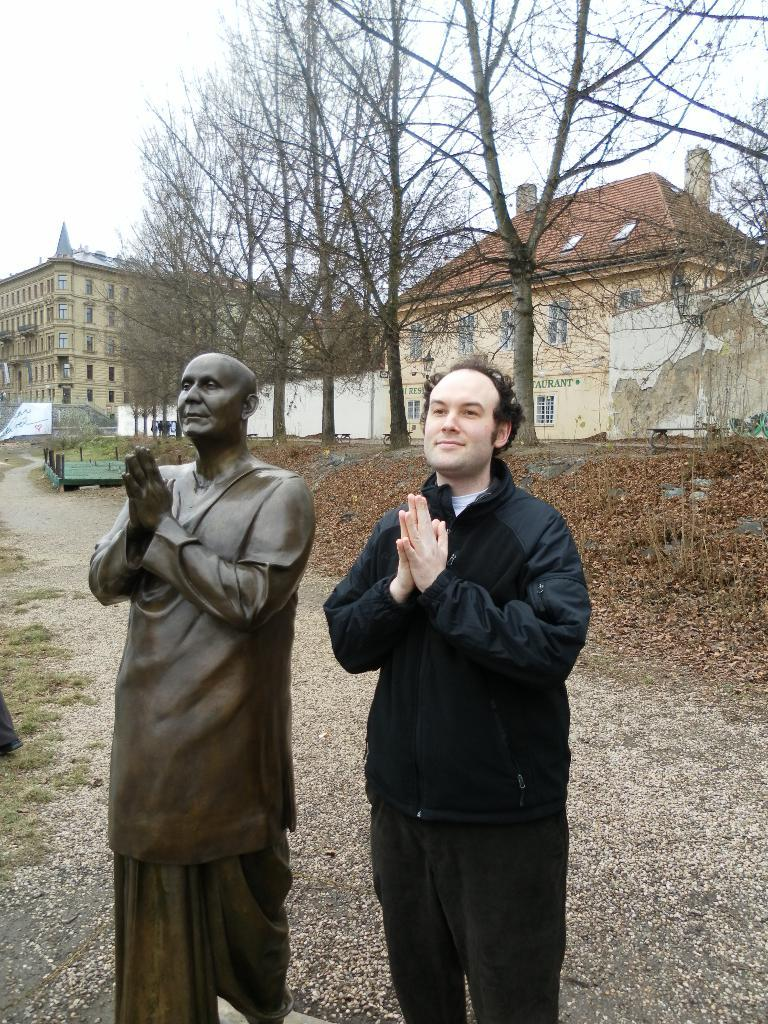What is the man in the image standing beside? The man is standing beside a statue in the image. What can be seen in the background of the image? There are trees, houses, and the sky visible in the background of the image. What scent is emanating from the oatmeal in the image? There is no oatmeal present in the image, so it is not possible to determine any scent. 